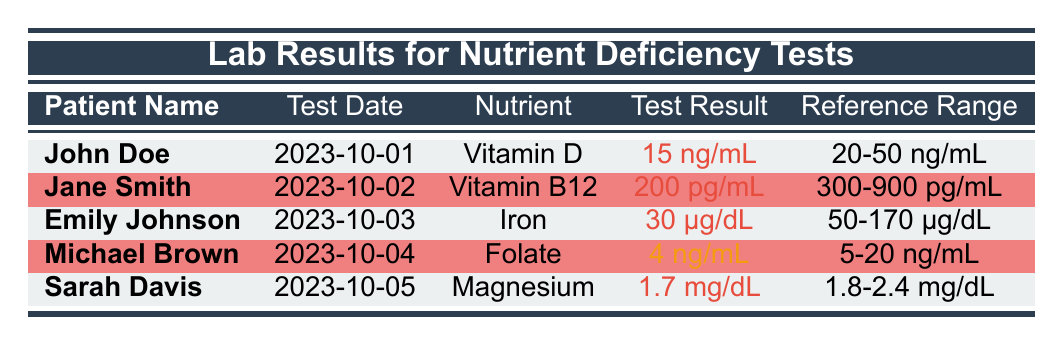What nutrient did John Doe have a deficit in? The table indicates that John Doe has a deficiency in Vitamin D. This can be directly found in the "nutrient" column for his row.
Answer: Vitamin D What was Emily Johnson's test result for Iron? The table shows that Emily Johnson's test result for Iron is 30 µg/dL. This can be found in the "test result" column corresponding to her name.
Answer: 30 µg/dL How many patients are deficient in nutrients based on the table? The table lists five patients, and all except Michael Brown are classified as deficient. Counting John Doe, Jane Smith, Emily Johnson, and Sarah Davis gives us four deficient patients.
Answer: 4 What is the reference range for Folate? Looking at the table, the reference range for Folate can be found in Michael Brown's row, which is 5-20 ng/mL.
Answer: 5-20 ng/mL Is Sarah Davis deficient in Magnesium? The table states that Sarah Davis is classified as deficient, as indicated in her deficiency status, which is noted as "Deficient."
Answer: Yes What is the average test result value for the patients who are deficient? We add up the test results for the deficient patients: 15 + 200 + 30 + 1.7 = 246. The total number of deficient patients is 4. Thus, the average is 246/4 = 61.5.
Answer: 61.5 What is the difference between the test result of Vitamin B12 and Iron? The test result for Vitamin B12 is 200 pg/mL, and for Iron, it is 30 µg/dL (which we convert to pg/mL; 1 µg/dL = 10 pg/mL, so 30 µg/dL = 3000 pg/mL). The difference is 3000 - 200 = 2800 pg/mL.
Answer: 2800 pg/mL How many patients had marginal deficiency? The table shows that only Michael Brown has a marginal deficiency status for Folate, which is the only entry classified this way.
Answer: 1 Was there a test date for Jane Smith listed in the results? The table clearly states that Jane Smith's test date is 2023-10-02, confirming that there is indeed a test date for her.
Answer: Yes 